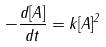Convert formula to latex. <formula><loc_0><loc_0><loc_500><loc_500>- \frac { d [ A ] } { d t } = k [ A ] ^ { 2 }</formula> 